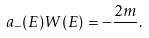Convert formula to latex. <formula><loc_0><loc_0><loc_500><loc_500>a _ { - } ( E ) W ( E ) = - \frac { 2 m } { } .</formula> 